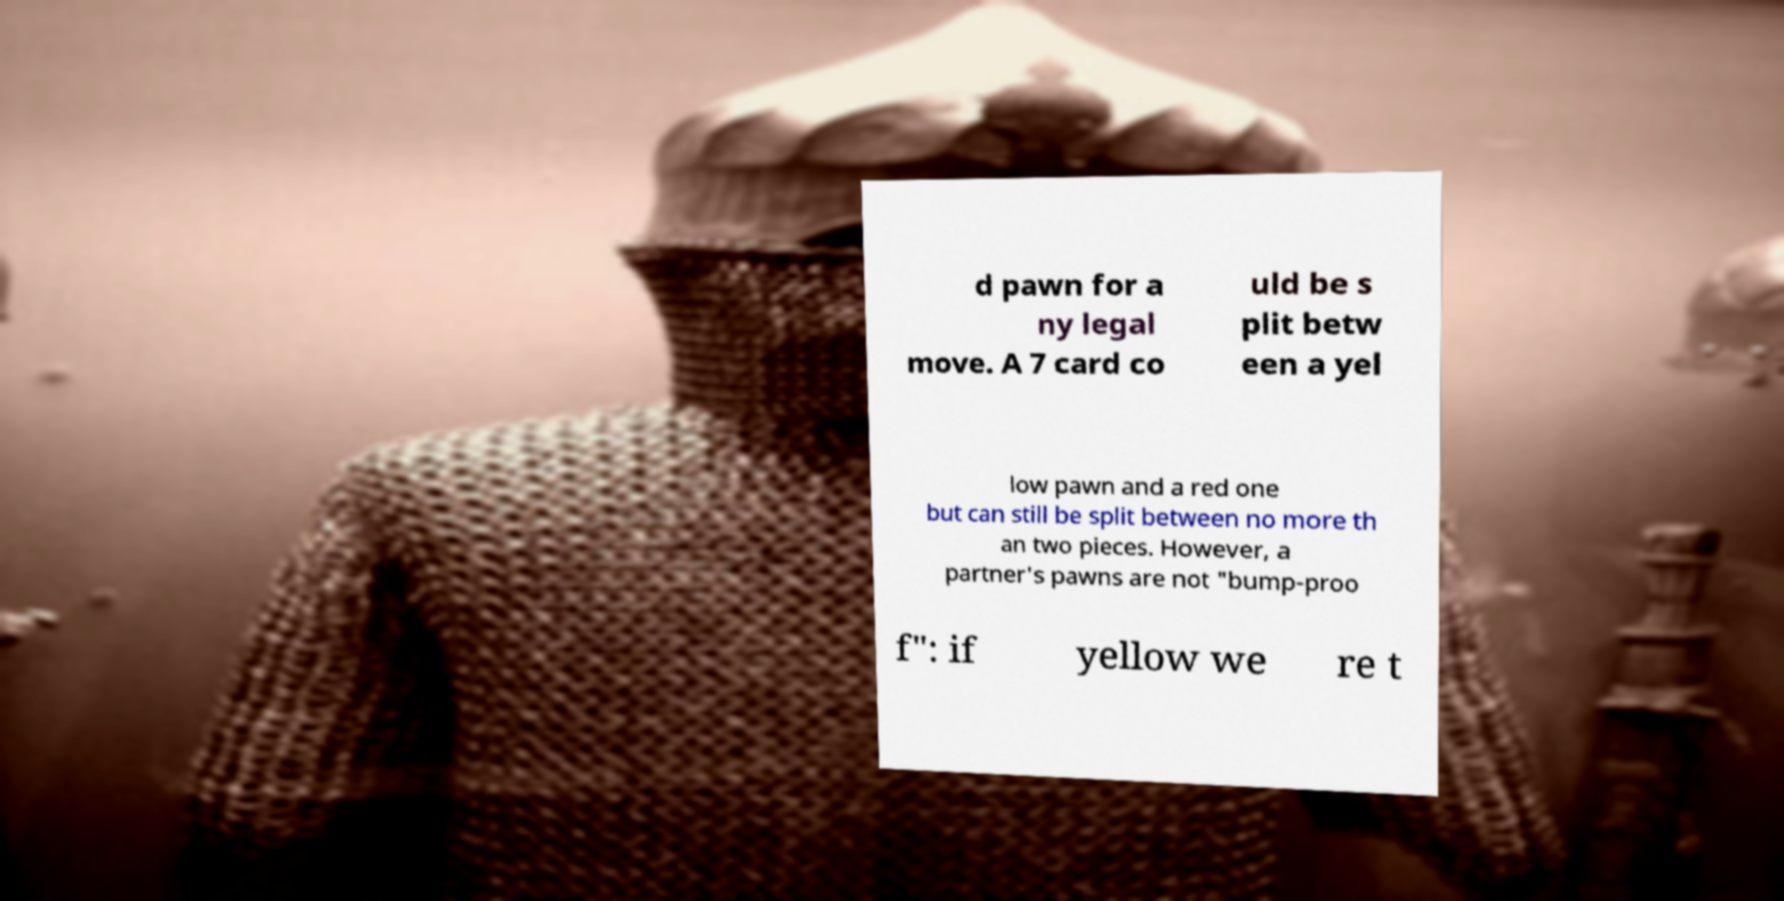There's text embedded in this image that I need extracted. Can you transcribe it verbatim? d pawn for a ny legal move. A 7 card co uld be s plit betw een a yel low pawn and a red one but can still be split between no more th an two pieces. However, a partner's pawns are not "bump-proo f": if yellow we re t 